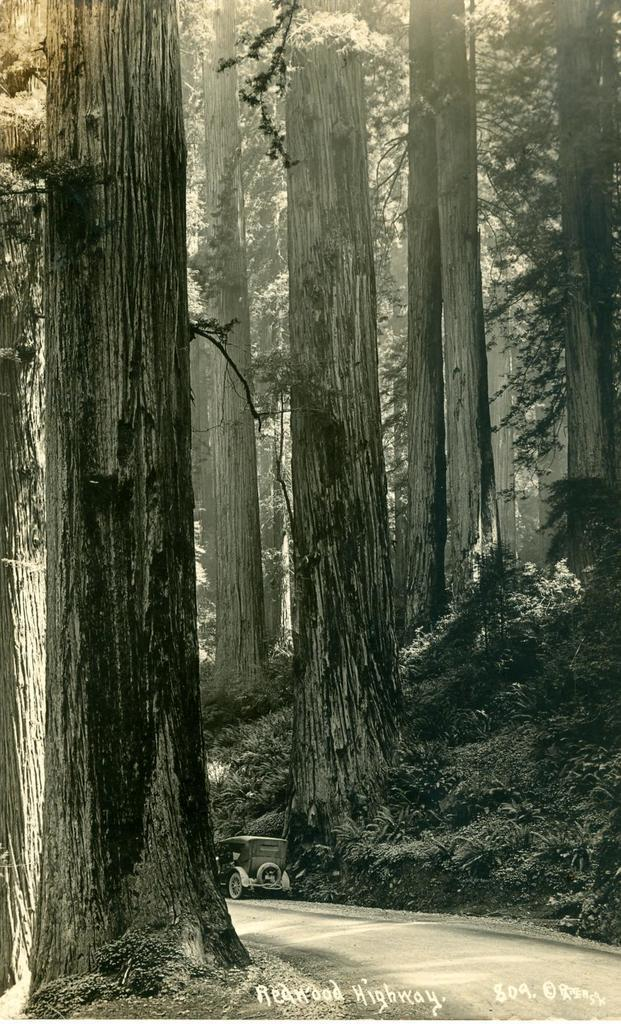What type of natural elements can be seen in the image? There are trees in the image. What type of man-made object is present on the road in the image? There is a vehicle on the road in the image. Is there any text or logo visible in the image? Yes, there is a watermark visible in the image. Can you see a nest in the trees in the image? There is no nest visible in the trees in the image. What invention is being used to create icicles in the image? There are no icicles present in the image, and no invention is being used to create them. 